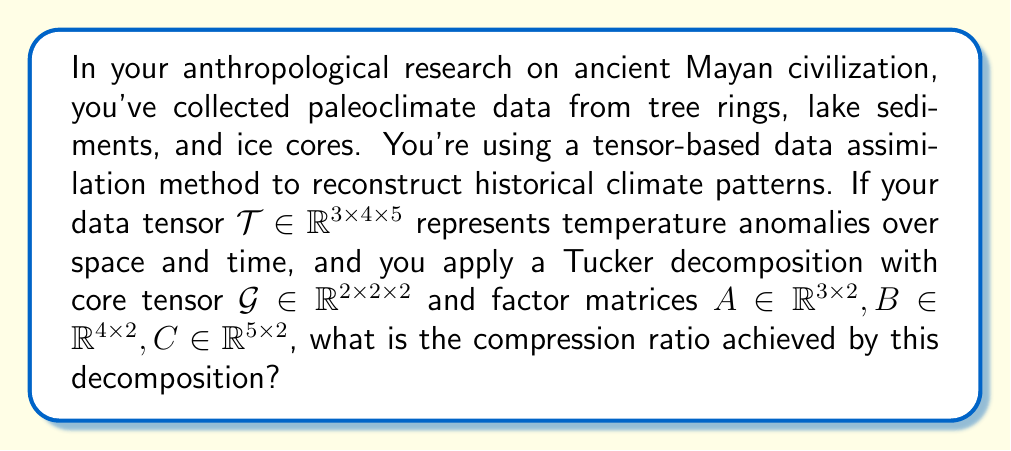Teach me how to tackle this problem. Let's approach this step-by-step:

1) First, we need to calculate the number of elements in the original tensor $\mathcal{T}$:
   $$N_{\mathcal{T}} = 3 \times 4 \times 5 = 60$$

2) Next, we calculate the number of elements in the decomposed representation:
   
   a) Core tensor $\mathcal{G}$: $2 \times 2 \times 2 = 8$ elements
   b) Factor matrix $A$: $3 \times 2 = 6$ elements
   c) Factor matrix $B$: $4 \times 2 = 8$ elements
   d) Factor matrix $C$: $5 \times 2 = 10$ elements

   Total elements in decomposition: $N_D = 8 + 6 + 8 + 10 = 32$

3) The compression ratio is defined as the ratio of the original number of elements to the number of elements in the decomposed representation:

   $$\text{Compression Ratio} = \frac{N_{\mathcal{T}}}{N_D} = \frac{60}{32} = \frac{15}{8} = 1.875$$

This means that the decomposed representation uses only about 53.33% of the storage required by the original tensor, achieving a compression of about 46.67%.
Answer: $1.875$ 